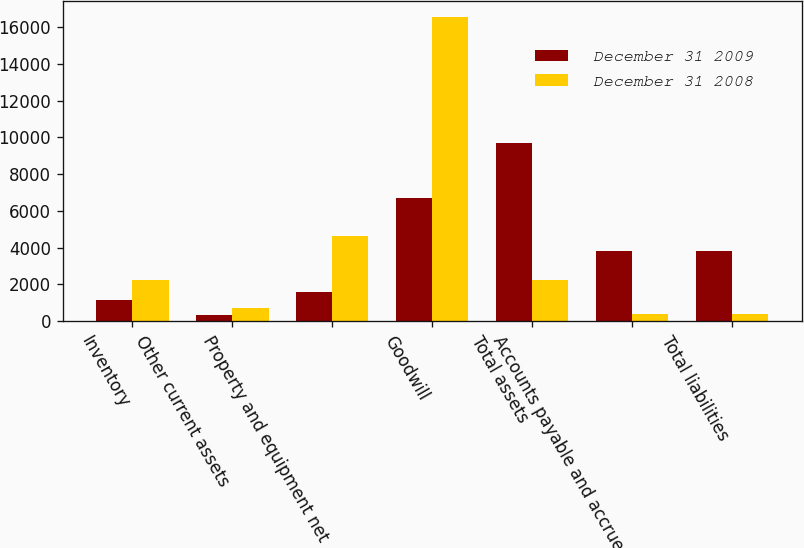Convert chart. <chart><loc_0><loc_0><loc_500><loc_500><stacked_bar_chart><ecel><fcel>Inventory<fcel>Other current assets<fcel>Property and equipment net<fcel>Goodwill<fcel>Total assets<fcel>Accounts payable and accrued<fcel>Total liabilities<nl><fcel>December 31 2009<fcel>1152<fcel>307<fcel>1553<fcel>6708<fcel>9720<fcel>3832<fcel>3832<nl><fcel>December 31 2008<fcel>2245<fcel>685<fcel>4610<fcel>16589<fcel>2245<fcel>354<fcel>354<nl></chart> 